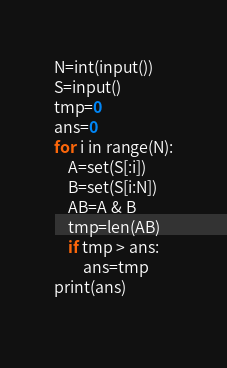<code> <loc_0><loc_0><loc_500><loc_500><_Python_>N=int(input())
S=input()
tmp=0
ans=0
for i in range(N):
    A=set(S[:i])
    B=set(S[i:N])
    AB=A & B
    tmp=len(AB)
    if tmp > ans:
        ans=tmp
print(ans)
            
</code> 